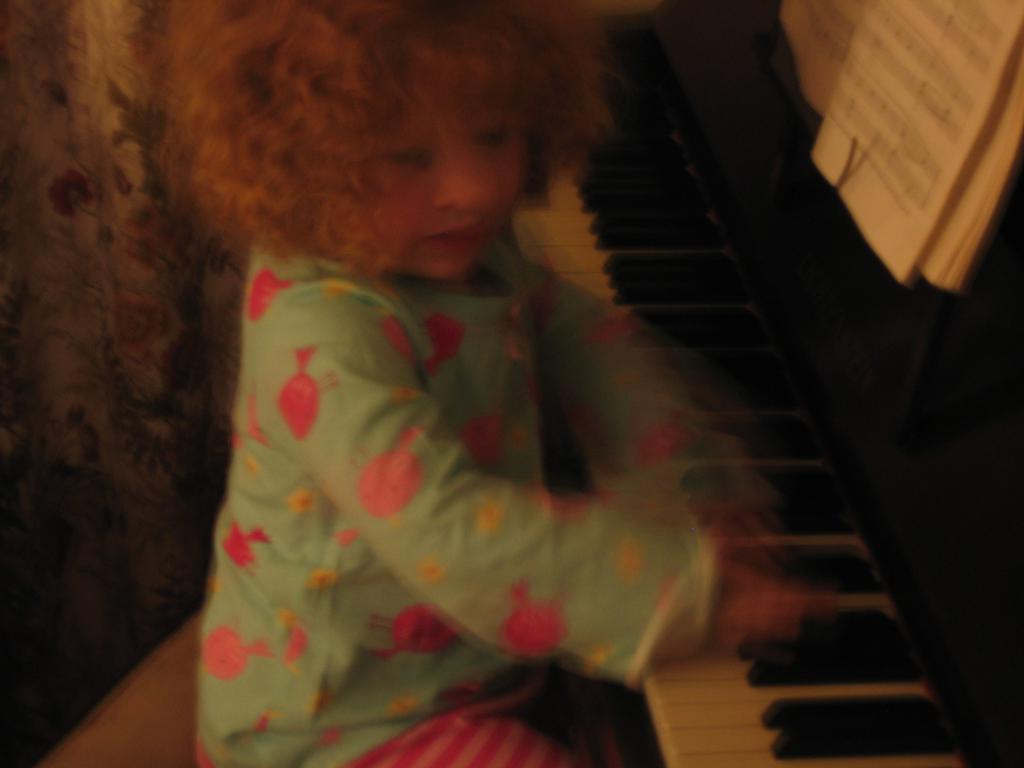In one or two sentences, can you explain what this image depicts? In this picture is a small girl sitting on the chair in front of a piano playing the piano keys 